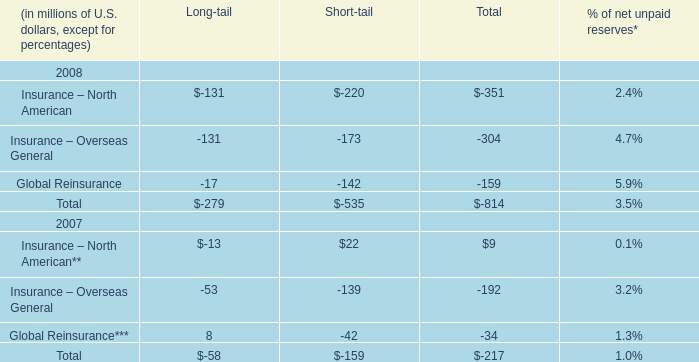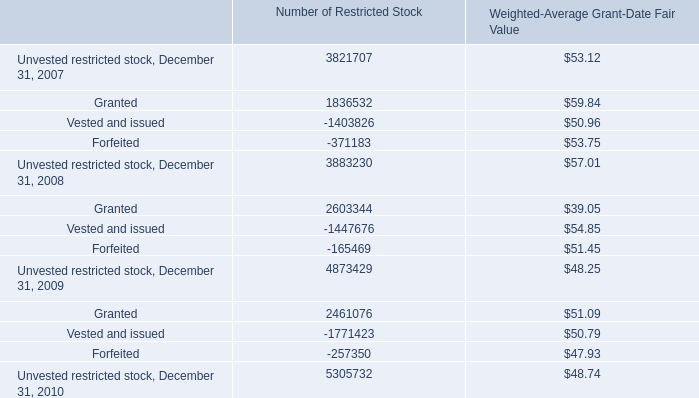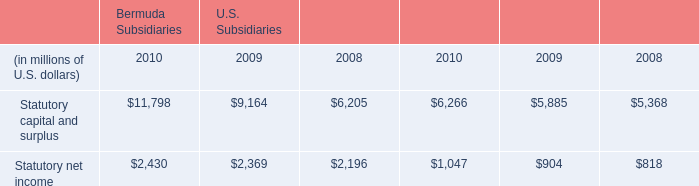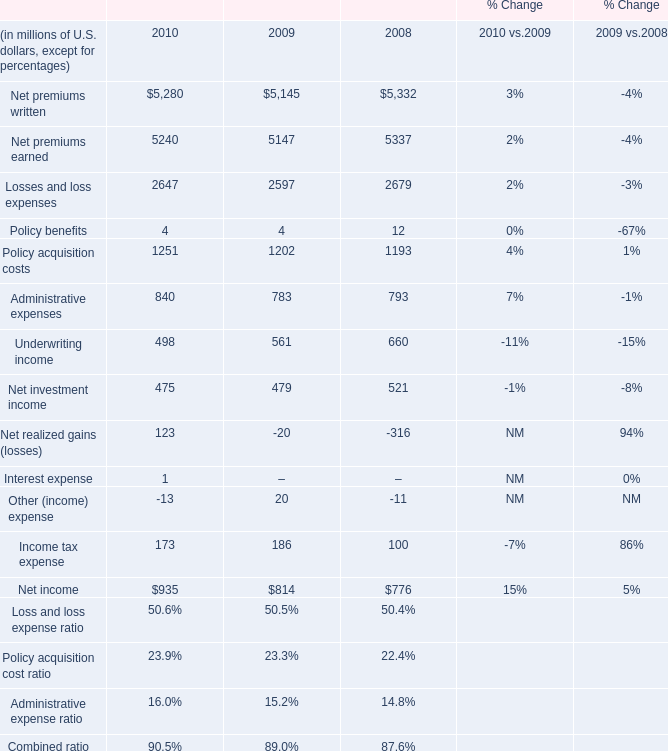What's the average of Forfeited of Number of Restricted Stock, and Statutory capital and surplus of U.S. Subsidiaries 2008 ? 
Computations: ((371183.0 + 6205.0) / 2)
Answer: 188694.0. 